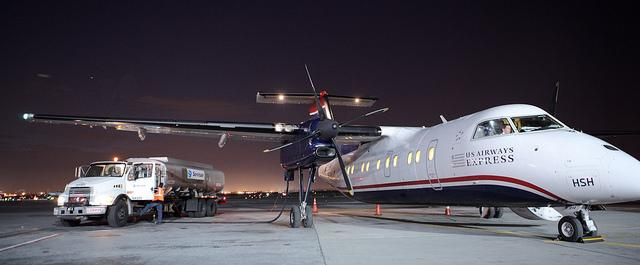What color is the underbelly of this private jet? Please explain your reasoning. black. The color is black. 